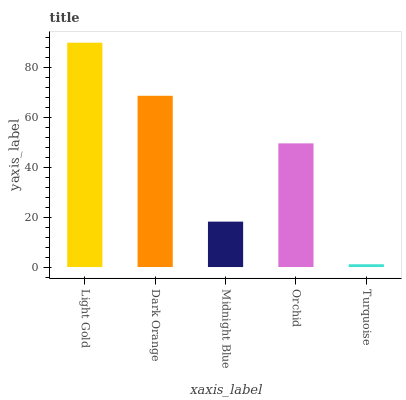Is Dark Orange the minimum?
Answer yes or no. No. Is Dark Orange the maximum?
Answer yes or no. No. Is Light Gold greater than Dark Orange?
Answer yes or no. Yes. Is Dark Orange less than Light Gold?
Answer yes or no. Yes. Is Dark Orange greater than Light Gold?
Answer yes or no. No. Is Light Gold less than Dark Orange?
Answer yes or no. No. Is Orchid the high median?
Answer yes or no. Yes. Is Orchid the low median?
Answer yes or no. Yes. Is Dark Orange the high median?
Answer yes or no. No. Is Light Gold the low median?
Answer yes or no. No. 